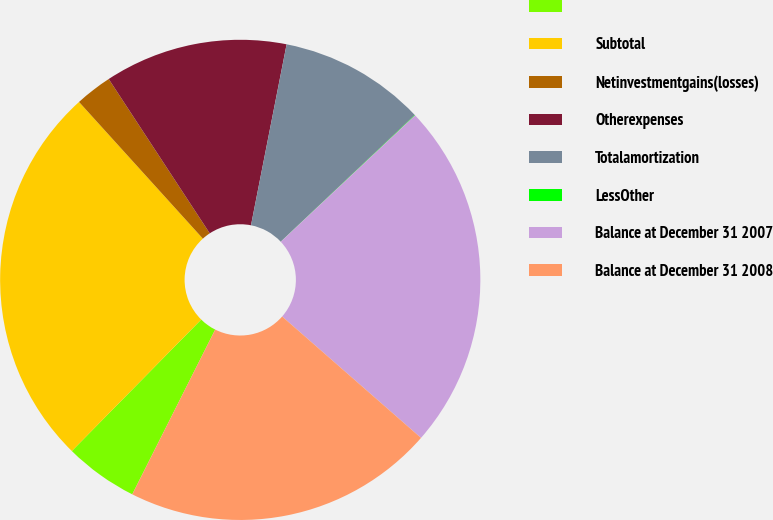Convert chart to OTSL. <chart><loc_0><loc_0><loc_500><loc_500><pie_chart><ecel><fcel>Subtotal<fcel>Netinvestmentgains(losses)<fcel>Otherexpenses<fcel>Totalamortization<fcel>LessOther<fcel>Balance at December 31 2007<fcel>Balance at December 31 2008<nl><fcel>4.95%<fcel>25.91%<fcel>2.49%<fcel>12.32%<fcel>9.86%<fcel>0.03%<fcel>23.45%<fcel>20.99%<nl></chart> 